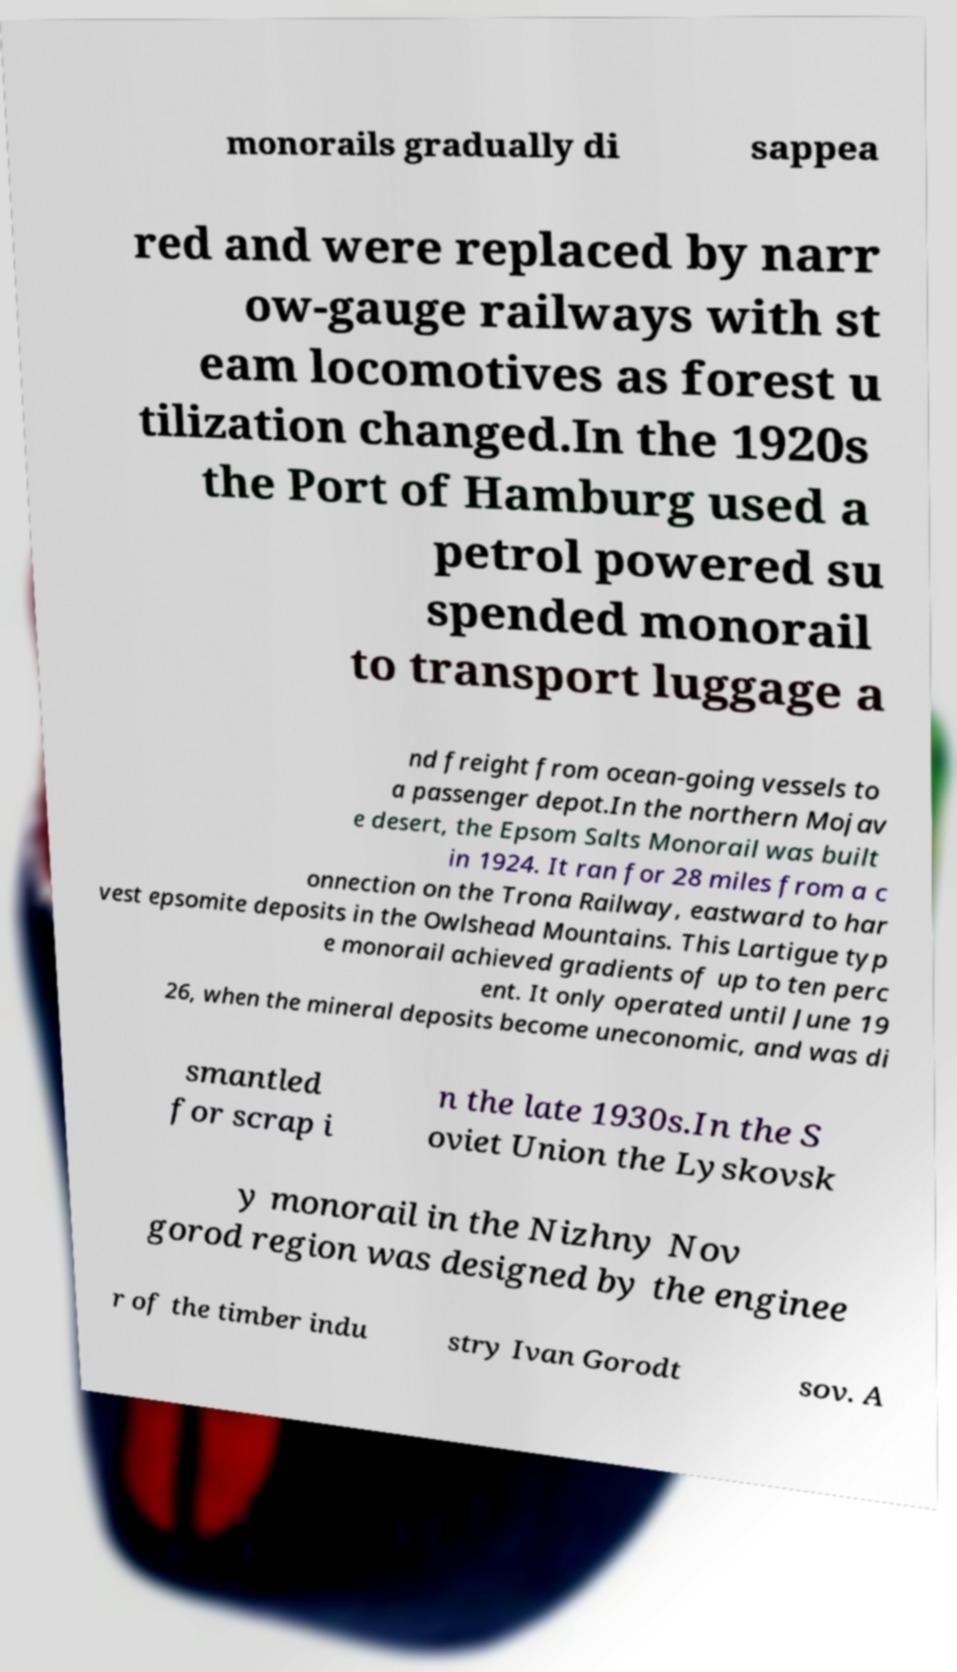There's text embedded in this image that I need extracted. Can you transcribe it verbatim? monorails gradually di sappea red and were replaced by narr ow-gauge railways with st eam locomotives as forest u tilization changed.In the 1920s the Port of Hamburg used a petrol powered su spended monorail to transport luggage a nd freight from ocean-going vessels to a passenger depot.In the northern Mojav e desert, the Epsom Salts Monorail was built in 1924. It ran for 28 miles from a c onnection on the Trona Railway, eastward to har vest epsomite deposits in the Owlshead Mountains. This Lartigue typ e monorail achieved gradients of up to ten perc ent. It only operated until June 19 26, when the mineral deposits become uneconomic, and was di smantled for scrap i n the late 1930s.In the S oviet Union the Lyskovsk y monorail in the Nizhny Nov gorod region was designed by the enginee r of the timber indu stry Ivan Gorodt sov. A 